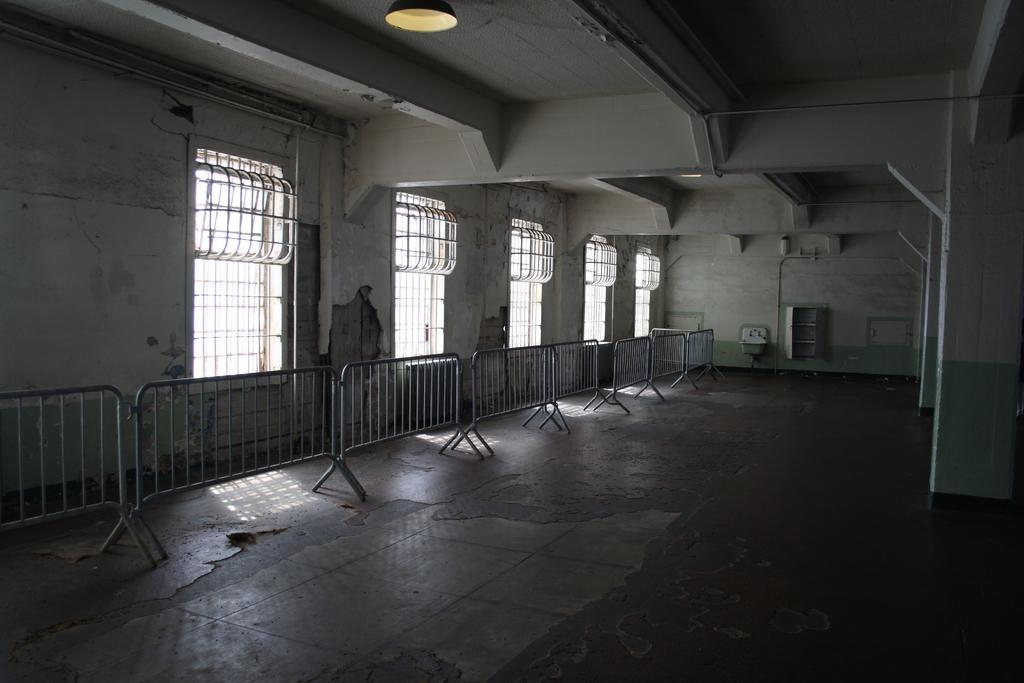How would you summarize this image in a sentence or two? In this image we can see a building, grills, barrier poles, and walls. 